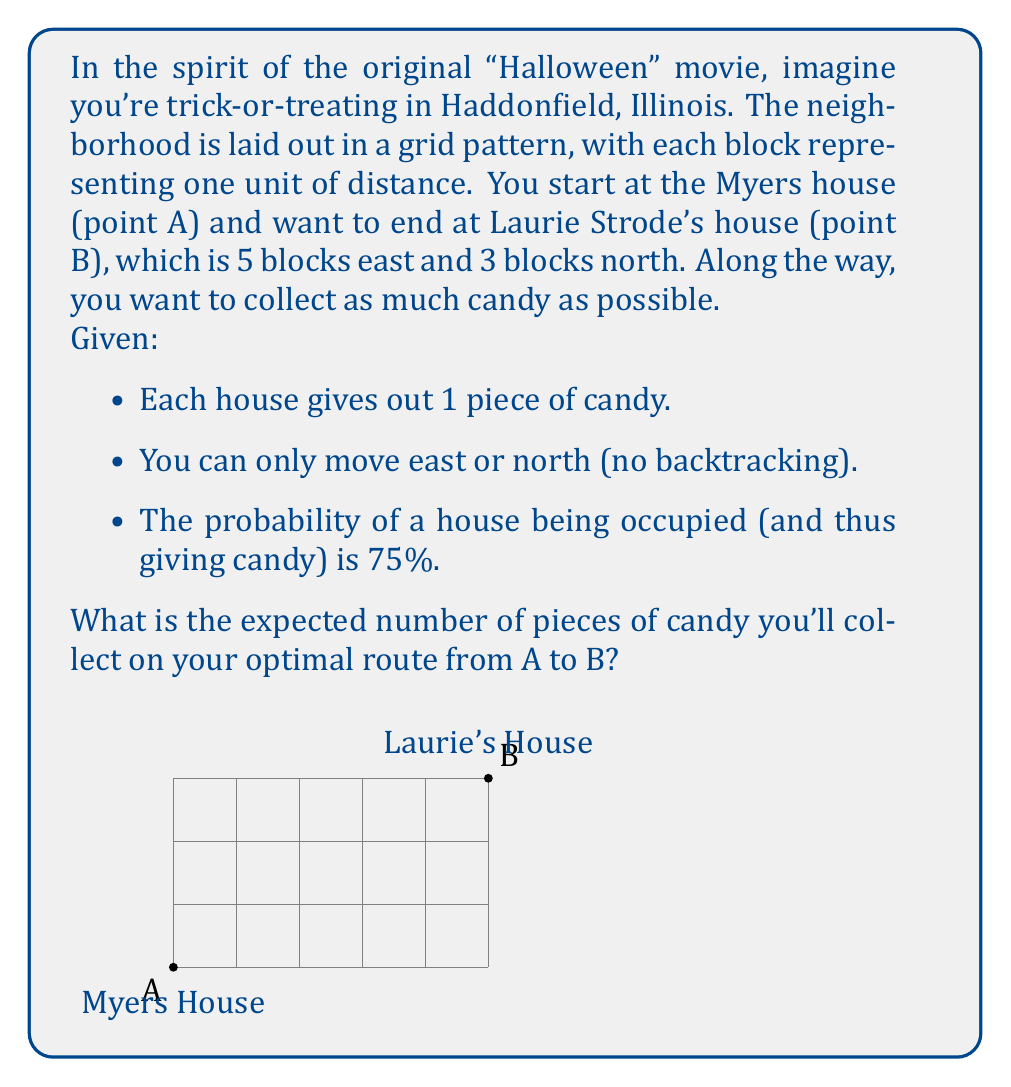Teach me how to tackle this problem. Let's approach this step-by-step:

1) First, we need to determine the total number of steps in any path from A to B:
   - We must go 5 blocks east and 3 blocks north.
   - Total steps = 5 + 3 = 8

2) Now, we need to consider how many houses we'll pass:
   - In a grid, the number of houses we pass is equal to the number of steps we take.
   - So, we'll pass 8 houses.

3) The probability of getting candy at each house is 75% or 0.75.

4) To calculate the expected number of pieces of candy, we use the formula:
   $$ E(X) = n \cdot p $$
   Where:
   $E(X)$ is the expected value
   $n$ is the number of trials (houses passed)
   $p$ is the probability of success (getting candy)

5) Plugging in our values:
   $$ E(X) = 8 \cdot 0.75 = 6 $$

6) Therefore, the expected number of pieces of candy is 6.

Note: This problem is an application of the binomial distribution, where the expected value is simply the number of trials multiplied by the probability of success for each trial.
Answer: 6 pieces of candy 